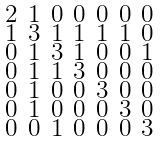<formula> <loc_0><loc_0><loc_500><loc_500>\begin{smallmatrix} 2 & 1 & 0 & 0 & 0 & 0 & 0 \\ 1 & 3 & 1 & 1 & 1 & 1 & 0 \\ 0 & 1 & 3 & 1 & 0 & 0 & 1 \\ 0 & 1 & 1 & 3 & 0 & 0 & 0 \\ 0 & 1 & 0 & 0 & 3 & 0 & 0 \\ 0 & 1 & 0 & 0 & 0 & 3 & 0 \\ 0 & 0 & 1 & 0 & 0 & 0 & 3 \end{smallmatrix}</formula> 